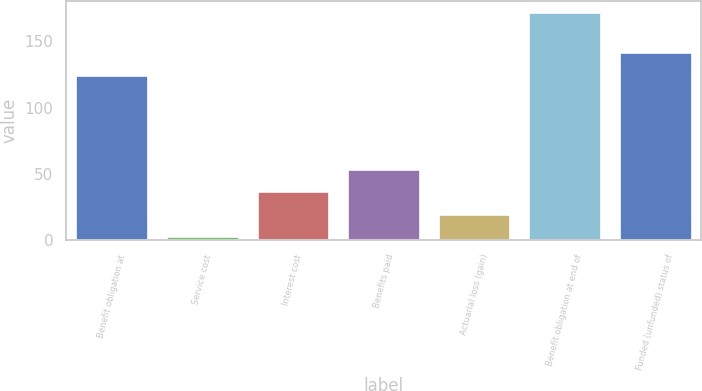Convert chart to OTSL. <chart><loc_0><loc_0><loc_500><loc_500><bar_chart><fcel>Benefit obligation at<fcel>Service cost<fcel>Interest cost<fcel>Benefits paid<fcel>Actuarial loss (gain)<fcel>Benefit obligation at end of<fcel>Funded (unfunded) status of<nl><fcel>125<fcel>3<fcel>36.8<fcel>53.7<fcel>19.9<fcel>172<fcel>141.9<nl></chart> 